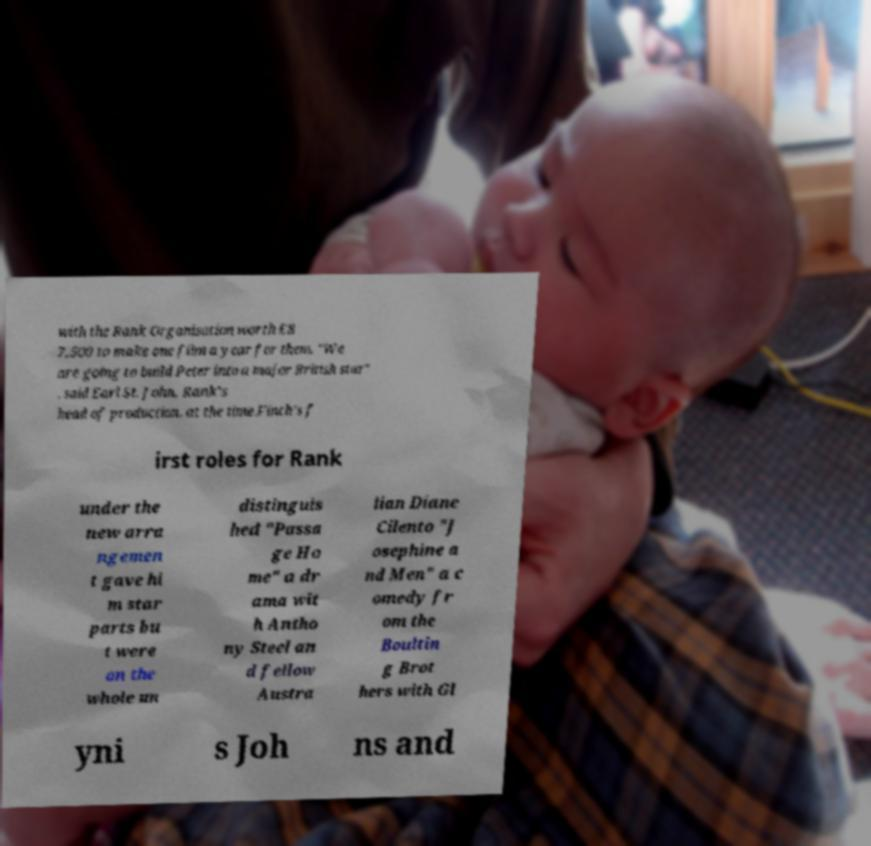I need the written content from this picture converted into text. Can you do that? with the Rank Organisation worth £8 7,500 to make one film a year for them. "We are going to build Peter into a major British star" , said Earl St. John, Rank's head of production, at the time.Finch's f irst roles for Rank under the new arra ngemen t gave hi m star parts bu t were on the whole un distinguis hed "Passa ge Ho me" a dr ama wit h Antho ny Steel an d fellow Austra lian Diane Cilento "J osephine a nd Men" a c omedy fr om the Boultin g Brot hers with Gl yni s Joh ns and 